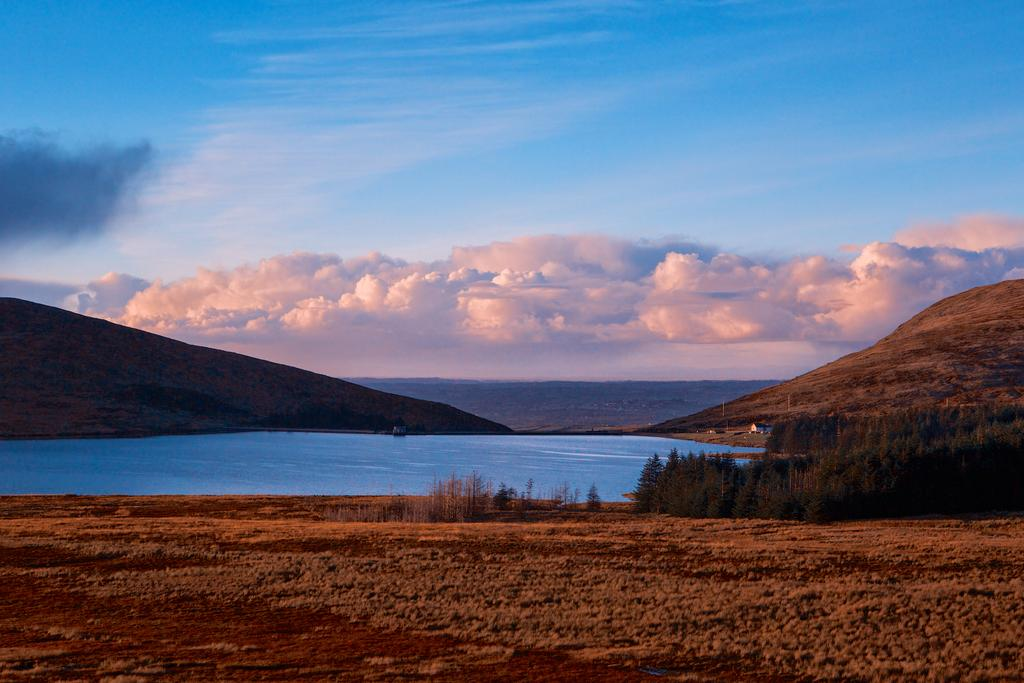What type of terrain can be seen in the image? The ground is visible in the image, and there are hills present. What natural elements are visible in the image? There are trees and water visible in the image. What is visible in the background of the image? The sky is visible in the background of the image, and clouds are present. What type of window can be seen in the image? There is no window present in the image. What is the competition about in the image? There is no competition depicted in the image. 